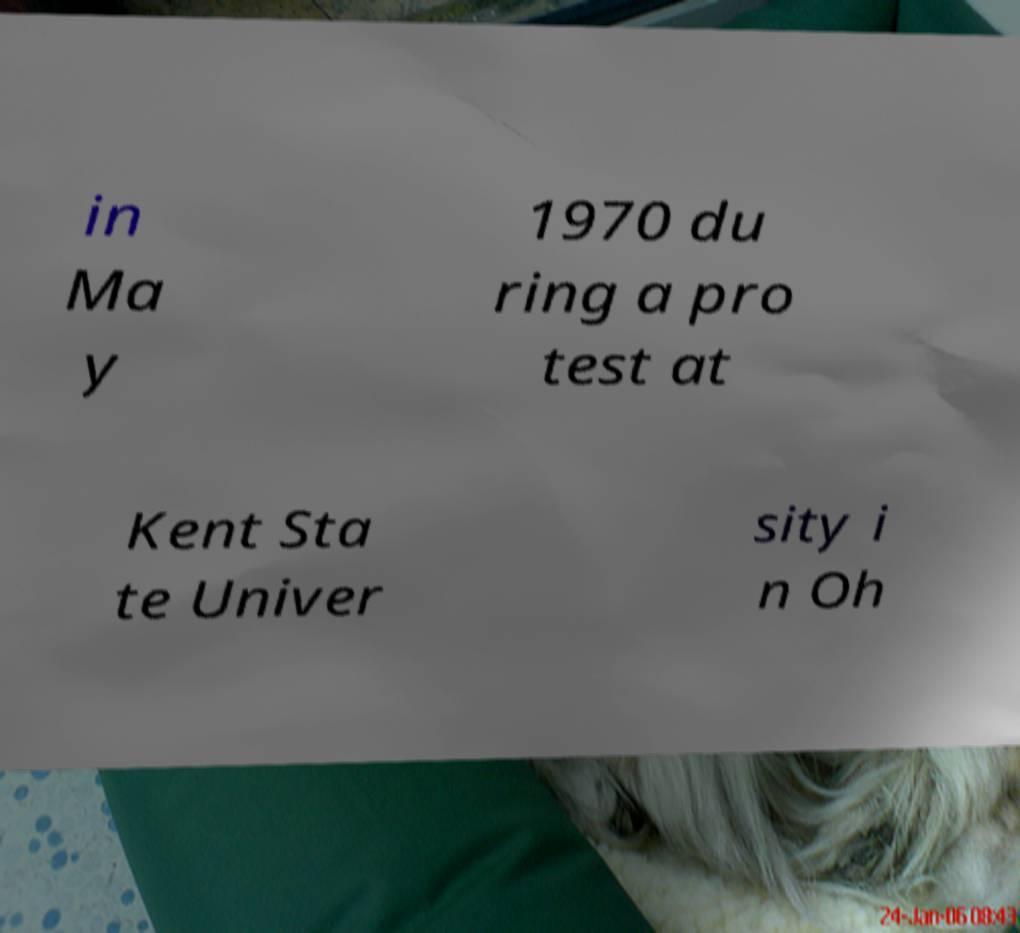I need the written content from this picture converted into text. Can you do that? in Ma y 1970 du ring a pro test at Kent Sta te Univer sity i n Oh 